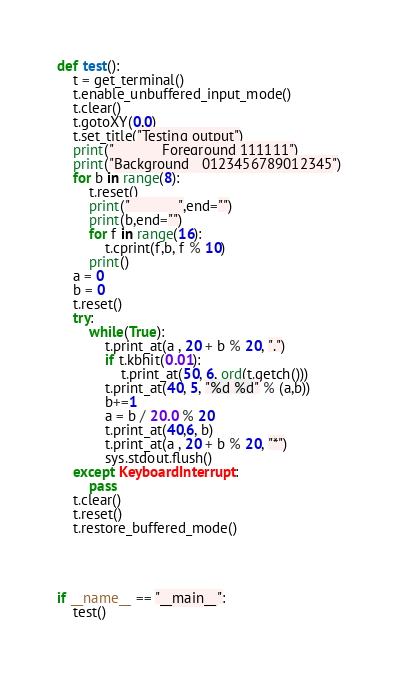Convert code to text. <code><loc_0><loc_0><loc_500><loc_500><_Python_>def test():
    t = get_terminal()
    t.enable_unbuffered_input_mode()
    t.clear()
    t.gotoXY(0,0)
    t.set_title("Testing output")
    print("            Foreground 111111")
    print("Background   0123456789012345")
    for b in range(8):
        t.reset()
        print("            ",end="")
        print(b,end="")
        for f in range(16):
            t.cprint(f,b, f % 10)
        print()
    a = 0
    b = 0
    t.reset()
    try:
        while(True):
            t.print_at(a , 20 + b % 20, ".")
            if t.kbhit(0.01):
                t.print_at(50, 6, ord(t.getch()))
            t.print_at(40, 5, "%d %d" % (a,b))
            b+=1
            a = b / 20.0 % 20
            t.print_at(40,6, b)
            t.print_at(a , 20 + b % 20, "*")
            sys.stdout.flush()
    except KeyboardInterrupt:
        pass
    t.clear()
    t.reset()
    t.restore_buffered_mode()



               
if __name__ == "__main__":
    test()</code> 